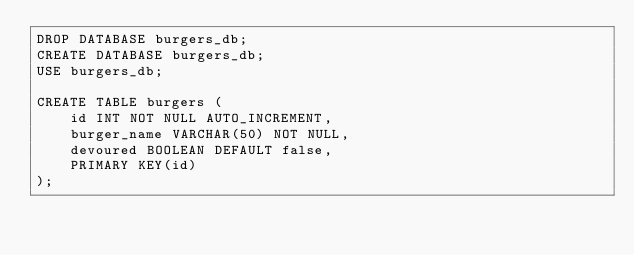Convert code to text. <code><loc_0><loc_0><loc_500><loc_500><_SQL_>DROP DATABASE burgers_db;
CREATE DATABASE burgers_db; 
USE burgers_db; 

CREATE TABLE burgers (
    id INT NOT NULL AUTO_INCREMENT, 
    burger_name VARCHAR(50) NOT NULL, 
    devoured BOOLEAN DEFAULT false, 
    PRIMARY KEY(id)
);</code> 